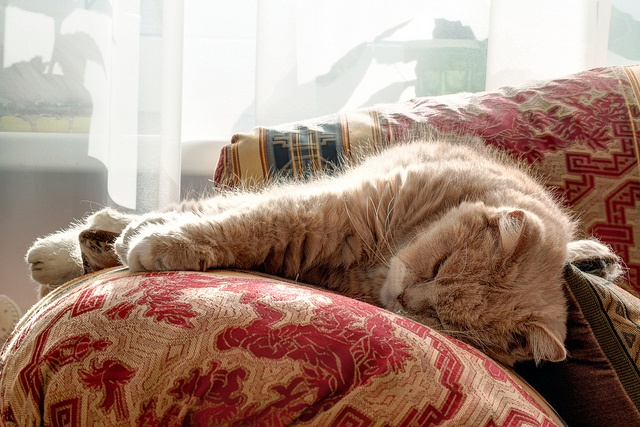Describe the objects in this image and their specific colors. I can see couch in lightgray, maroon, brown, and black tones and cat in lightgray, brown, gray, maroon, and ivory tones in this image. 